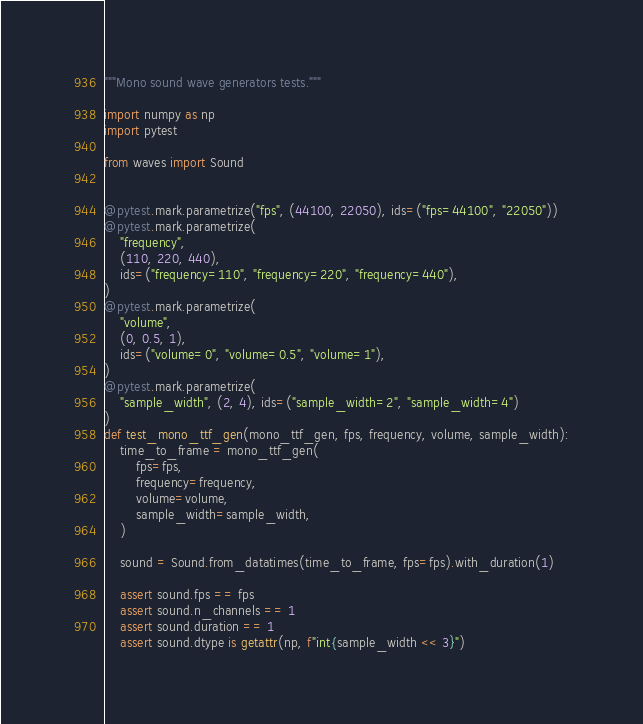Convert code to text. <code><loc_0><loc_0><loc_500><loc_500><_Python_>"""Mono sound wave generators tests."""

import numpy as np
import pytest

from waves import Sound


@pytest.mark.parametrize("fps", (44100, 22050), ids=("fps=44100", "22050"))
@pytest.mark.parametrize(
    "frequency",
    (110, 220, 440),
    ids=("frequency=110", "frequency=220", "frequency=440"),
)
@pytest.mark.parametrize(
    "volume",
    (0, 0.5, 1),
    ids=("volume=0", "volume=0.5", "volume=1"),
)
@pytest.mark.parametrize(
    "sample_width", (2, 4), ids=("sample_width=2", "sample_width=4")
)
def test_mono_ttf_gen(mono_ttf_gen, fps, frequency, volume, sample_width):
    time_to_frame = mono_ttf_gen(
        fps=fps,
        frequency=frequency,
        volume=volume,
        sample_width=sample_width,
    )

    sound = Sound.from_datatimes(time_to_frame, fps=fps).with_duration(1)

    assert sound.fps == fps
    assert sound.n_channels == 1
    assert sound.duration == 1
    assert sound.dtype is getattr(np, f"int{sample_width << 3}")
</code> 